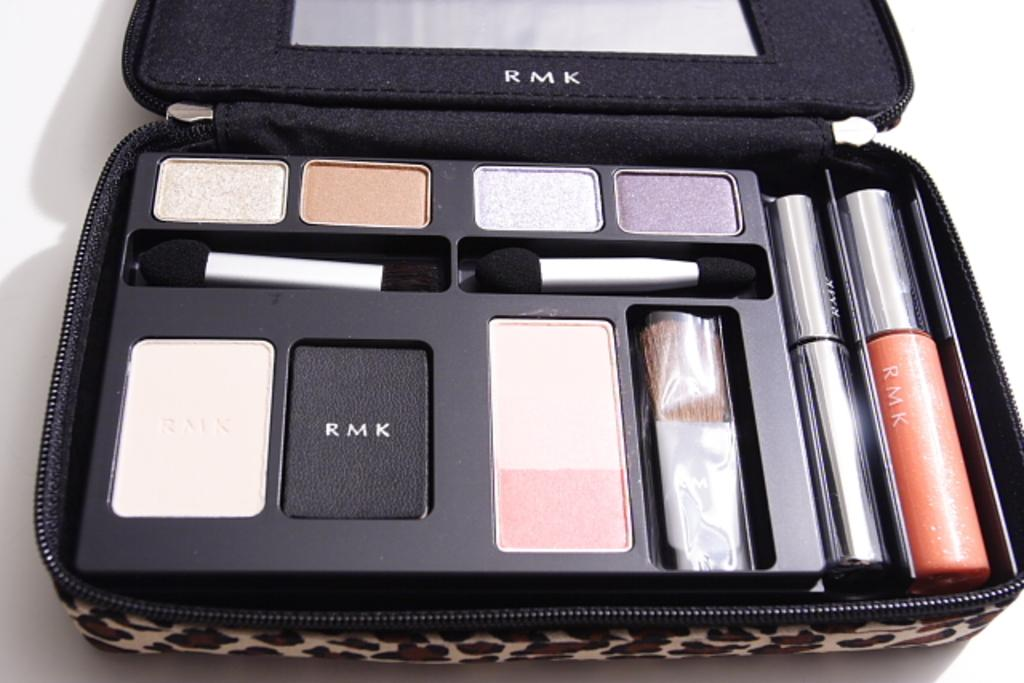What is the main object in the image? There is a makeup kit bag in the image. What items can be found inside the makeup kit bag? The makeup kit bag contains cosmetics and makeup brushes. What is the color of the background in the image? The background in the image is white. What type of substance is being transported in the journey depicted in the image? There is no journey or substance present in the image; it features a makeup kit bag with cosmetics and makeup brushes against a white background. 